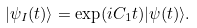Convert formula to latex. <formula><loc_0><loc_0><loc_500><loc_500>| \psi _ { I } ( t ) \rangle = \exp ( i C _ { 1 } t ) | \psi ( t ) \rangle .</formula> 